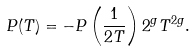Convert formula to latex. <formula><loc_0><loc_0><loc_500><loc_500>P ( T ) = - P \left ( \frac { 1 } { 2 T } \right ) 2 ^ { g } T ^ { 2 g } .</formula> 